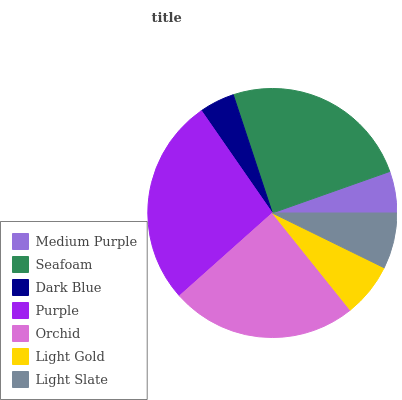Is Dark Blue the minimum?
Answer yes or no. Yes. Is Purple the maximum?
Answer yes or no. Yes. Is Seafoam the minimum?
Answer yes or no. No. Is Seafoam the maximum?
Answer yes or no. No. Is Seafoam greater than Medium Purple?
Answer yes or no. Yes. Is Medium Purple less than Seafoam?
Answer yes or no. Yes. Is Medium Purple greater than Seafoam?
Answer yes or no. No. Is Seafoam less than Medium Purple?
Answer yes or no. No. Is Light Slate the high median?
Answer yes or no. Yes. Is Light Slate the low median?
Answer yes or no. Yes. Is Purple the high median?
Answer yes or no. No. Is Medium Purple the low median?
Answer yes or no. No. 